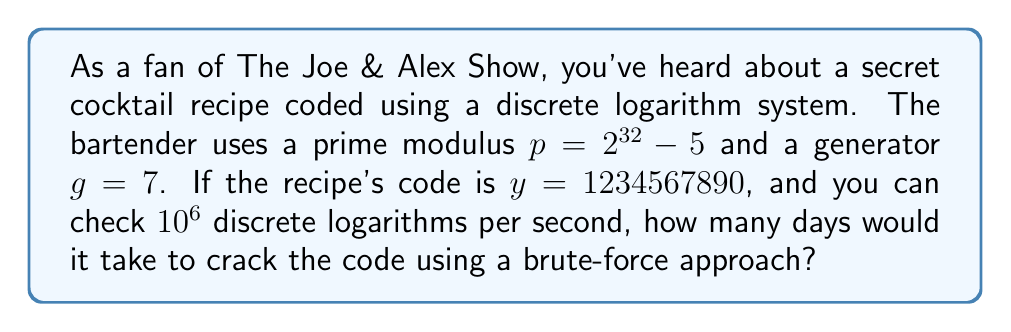Help me with this question. 1. The discrete logarithm problem is to find $x$ such that $g^x \equiv y \pmod{p}$.

2. The prime modulus is $p = 2^{32} - 5 = 4294967291$.

3. In the worst-case scenario, we need to check all possible values of $x$ from 1 to $p-1$.

4. The number of checks required is $p - 1 = 4294967290$.

5. We can perform $10^6$ checks per second.

6. Time required in seconds:
   $$\text{Time (seconds)} = \frac{4294967290}{10^6} = 4294.96729$$

7. Convert seconds to days:
   $$\text{Time (days)} = \frac{4294.96729}{86400} \approx 0.04971$$

8. Round up to the nearest hundredth of a day:
   $$\text{Time (days)} \approx 0.05$$
Answer: 0.05 days 